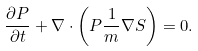<formula> <loc_0><loc_0><loc_500><loc_500>\frac { \partial P } { \partial t } + \nabla \cdot \left ( P \frac { 1 } { m } \nabla S \right ) = 0 .</formula> 